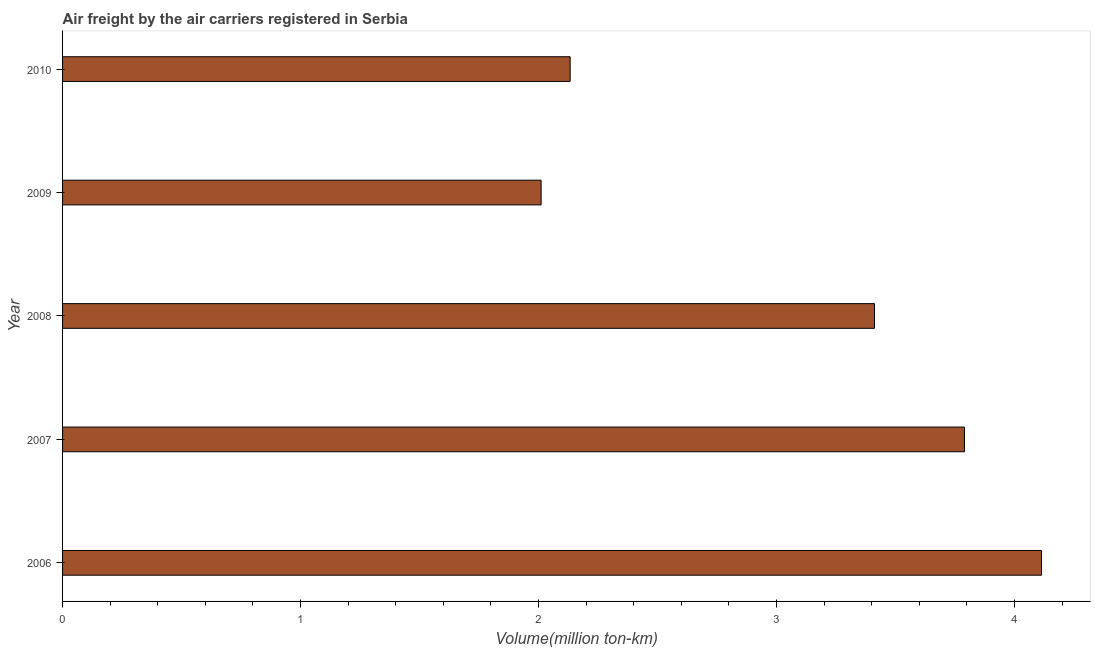Does the graph contain any zero values?
Offer a very short reply. No. What is the title of the graph?
Provide a short and direct response. Air freight by the air carriers registered in Serbia. What is the label or title of the X-axis?
Ensure brevity in your answer.  Volume(million ton-km). What is the air freight in 2010?
Your answer should be compact. 2.13. Across all years, what is the maximum air freight?
Provide a short and direct response. 4.11. Across all years, what is the minimum air freight?
Offer a terse response. 2.01. In which year was the air freight maximum?
Your answer should be very brief. 2006. What is the sum of the air freight?
Provide a succinct answer. 15.46. What is the difference between the air freight in 2006 and 2008?
Provide a short and direct response. 0.7. What is the average air freight per year?
Your answer should be compact. 3.09. What is the median air freight?
Keep it short and to the point. 3.41. Do a majority of the years between 2006 and 2010 (inclusive) have air freight greater than 2.2 million ton-km?
Your response must be concise. Yes. What is the ratio of the air freight in 2009 to that in 2010?
Provide a short and direct response. 0.94. Is the air freight in 2006 less than that in 2009?
Your response must be concise. No. What is the difference between the highest and the second highest air freight?
Provide a succinct answer. 0.32. What is the difference between the highest and the lowest air freight?
Provide a succinct answer. 2.1. In how many years, is the air freight greater than the average air freight taken over all years?
Provide a short and direct response. 3. How many bars are there?
Keep it short and to the point. 5. Are all the bars in the graph horizontal?
Provide a short and direct response. Yes. How many years are there in the graph?
Your answer should be very brief. 5. What is the difference between two consecutive major ticks on the X-axis?
Offer a terse response. 1. Are the values on the major ticks of X-axis written in scientific E-notation?
Provide a succinct answer. No. What is the Volume(million ton-km) in 2006?
Make the answer very short. 4.11. What is the Volume(million ton-km) of 2007?
Ensure brevity in your answer.  3.79. What is the Volume(million ton-km) of 2008?
Provide a short and direct response. 3.41. What is the Volume(million ton-km) of 2009?
Give a very brief answer. 2.01. What is the Volume(million ton-km) in 2010?
Ensure brevity in your answer.  2.13. What is the difference between the Volume(million ton-km) in 2006 and 2007?
Your response must be concise. 0.32. What is the difference between the Volume(million ton-km) in 2006 and 2008?
Your response must be concise. 0.7. What is the difference between the Volume(million ton-km) in 2006 and 2009?
Ensure brevity in your answer.  2.1. What is the difference between the Volume(million ton-km) in 2006 and 2010?
Make the answer very short. 1.98. What is the difference between the Volume(million ton-km) in 2007 and 2008?
Your response must be concise. 0.38. What is the difference between the Volume(million ton-km) in 2007 and 2009?
Give a very brief answer. 1.78. What is the difference between the Volume(million ton-km) in 2007 and 2010?
Keep it short and to the point. 1.66. What is the difference between the Volume(million ton-km) in 2008 and 2009?
Offer a very short reply. 1.4. What is the difference between the Volume(million ton-km) in 2008 and 2010?
Give a very brief answer. 1.28. What is the difference between the Volume(million ton-km) in 2009 and 2010?
Offer a terse response. -0.12. What is the ratio of the Volume(million ton-km) in 2006 to that in 2007?
Your answer should be very brief. 1.08. What is the ratio of the Volume(million ton-km) in 2006 to that in 2008?
Your answer should be compact. 1.21. What is the ratio of the Volume(million ton-km) in 2006 to that in 2009?
Ensure brevity in your answer.  2.05. What is the ratio of the Volume(million ton-km) in 2006 to that in 2010?
Keep it short and to the point. 1.93. What is the ratio of the Volume(million ton-km) in 2007 to that in 2008?
Ensure brevity in your answer.  1.11. What is the ratio of the Volume(million ton-km) in 2007 to that in 2009?
Provide a short and direct response. 1.89. What is the ratio of the Volume(million ton-km) in 2007 to that in 2010?
Your response must be concise. 1.78. What is the ratio of the Volume(million ton-km) in 2008 to that in 2009?
Provide a short and direct response. 1.7. What is the ratio of the Volume(million ton-km) in 2009 to that in 2010?
Your answer should be very brief. 0.94. 